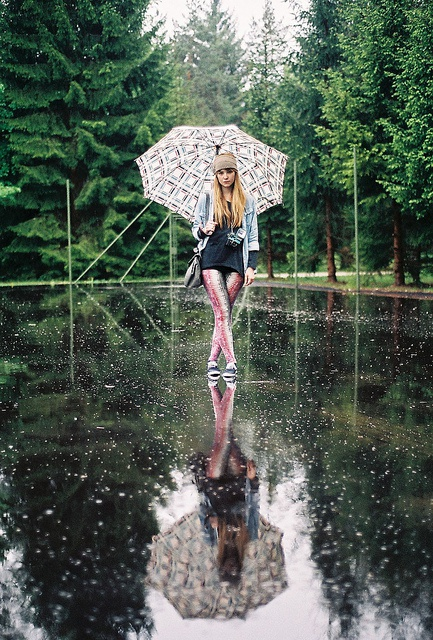Describe the objects in this image and their specific colors. I can see umbrella in black, lightgray, darkgray, and gray tones, people in black, lightgray, lightpink, and darkgray tones, and handbag in black, gray, darkgray, and lightgray tones in this image. 